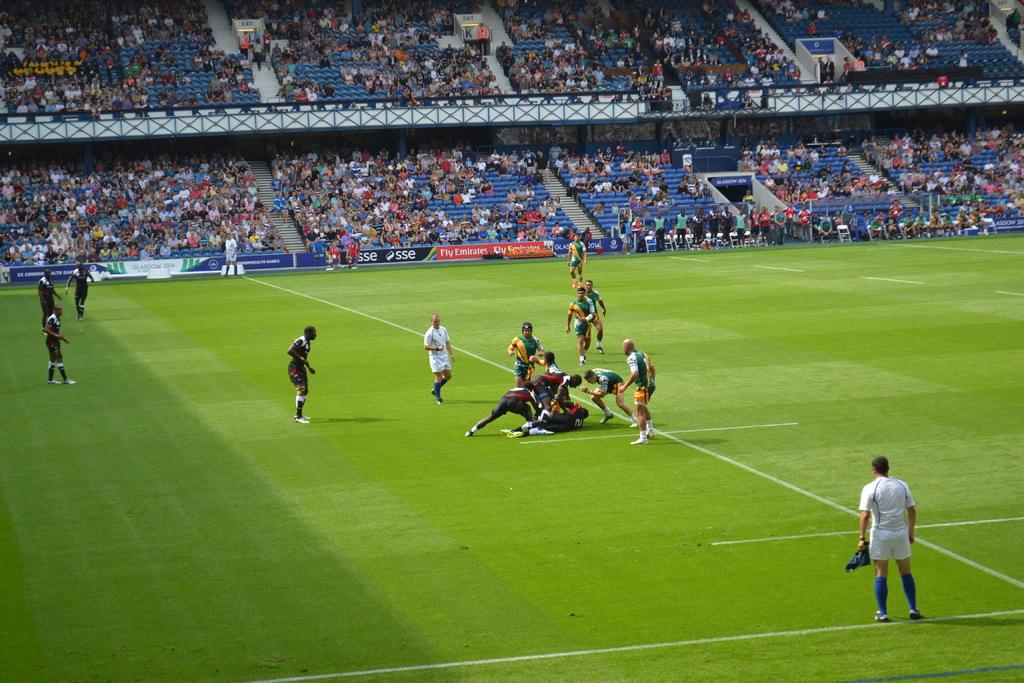What are the people in the image doing? The people in the image are playing on the ground. What can be seen in the background of the image? In the background of the image, there is a crowd, chairs, hoardings, steps, and other objects. How many elements can be identified in the background of the image? There are at least five elements in the background of the image: a crowd, chairs, hoardings, steps, and other objects. What type of harmony is being played by the people in the image? There is no indication in the image that the people are playing any type of harmony, as they are simply playing on the ground. What type of cushion is being used by the people in the image? There is no cushion visible in the image; the people are playing on the ground. 